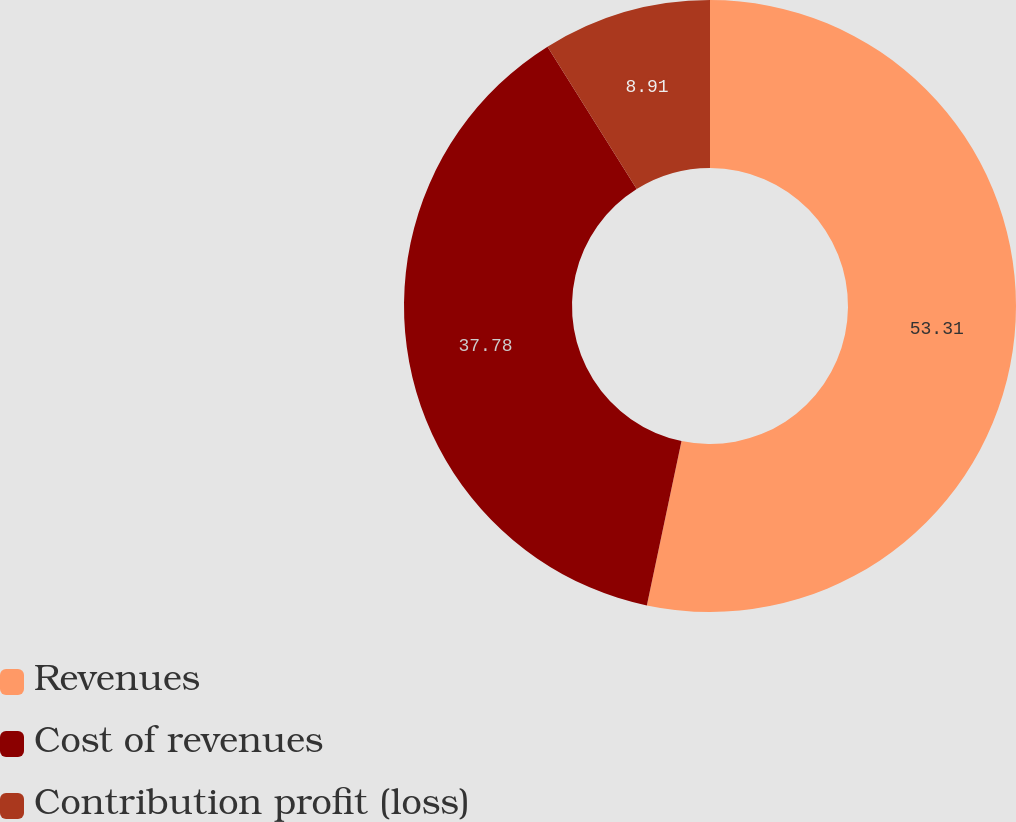Convert chart to OTSL. <chart><loc_0><loc_0><loc_500><loc_500><pie_chart><fcel>Revenues<fcel>Cost of revenues<fcel>Contribution profit (loss)<nl><fcel>53.31%<fcel>37.78%<fcel>8.91%<nl></chart> 